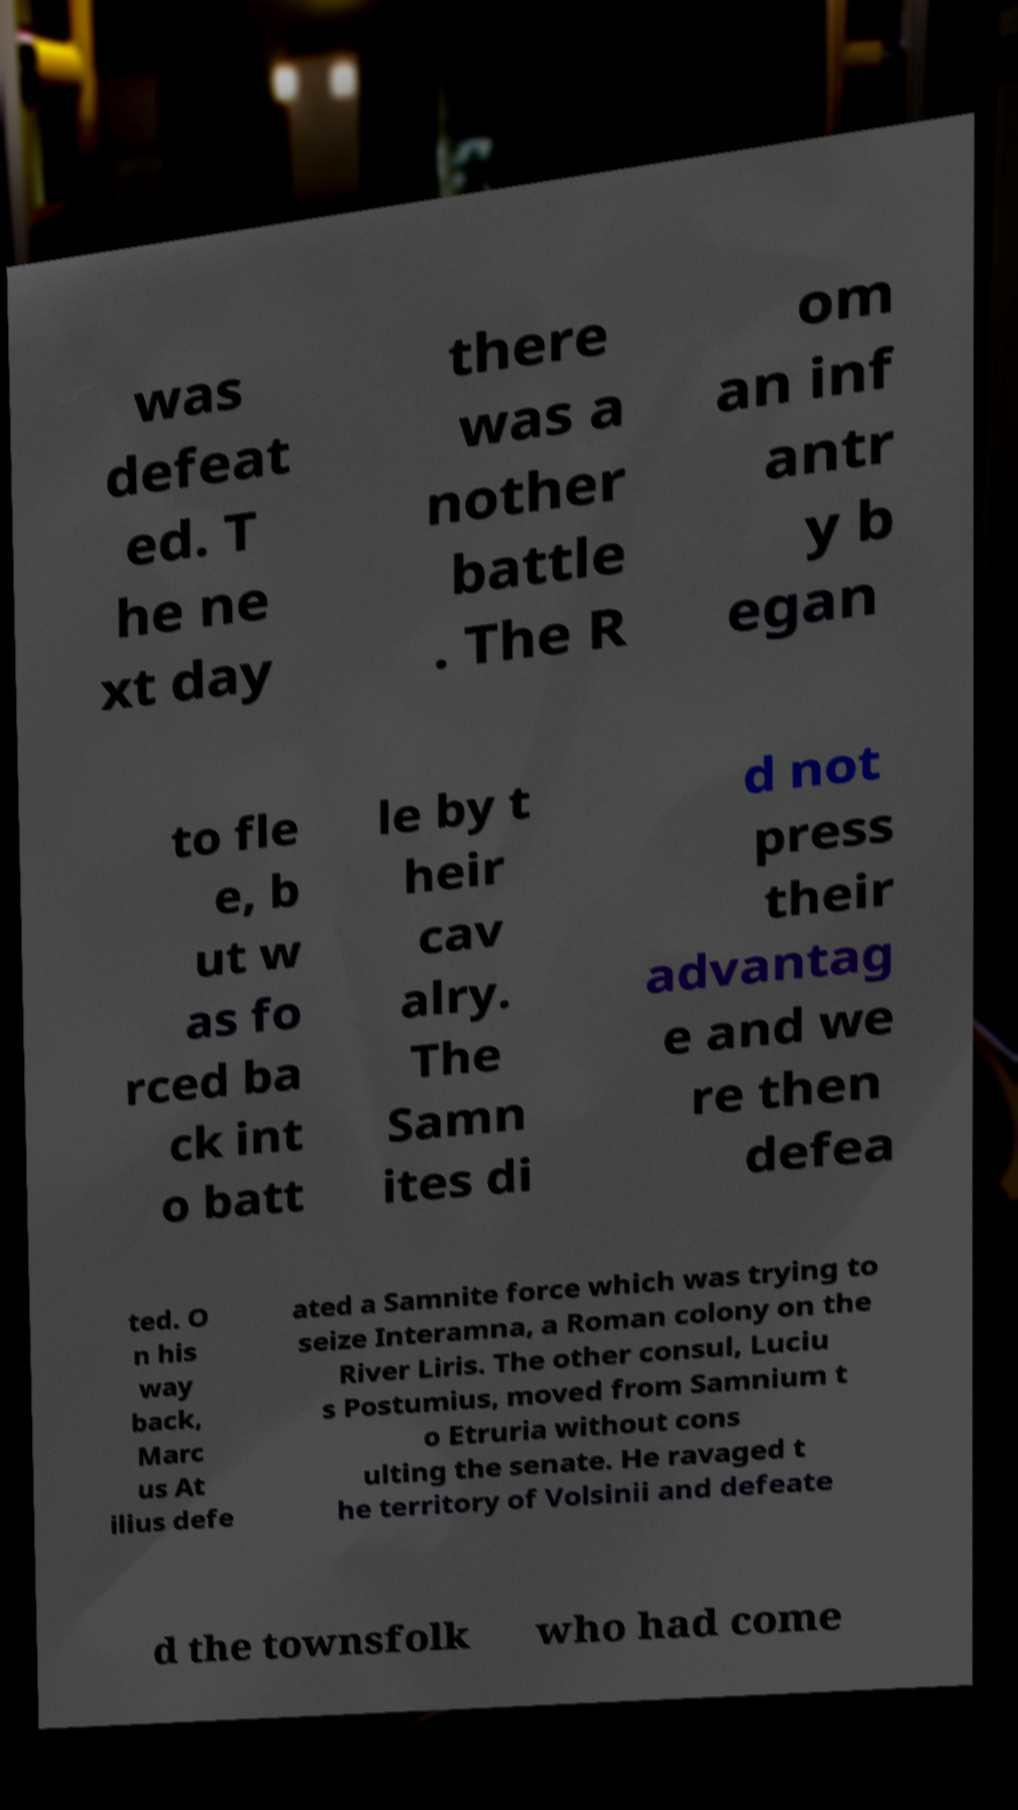Could you extract and type out the text from this image? was defeat ed. T he ne xt day there was a nother battle . The R om an inf antr y b egan to fle e, b ut w as fo rced ba ck int o batt le by t heir cav alry. The Samn ites di d not press their advantag e and we re then defea ted. O n his way back, Marc us At ilius defe ated a Samnite force which was trying to seize Interamna, a Roman colony on the River Liris. The other consul, Luciu s Postumius, moved from Samnium t o Etruria without cons ulting the senate. He ravaged t he territory of Volsinii and defeate d the townsfolk who had come 